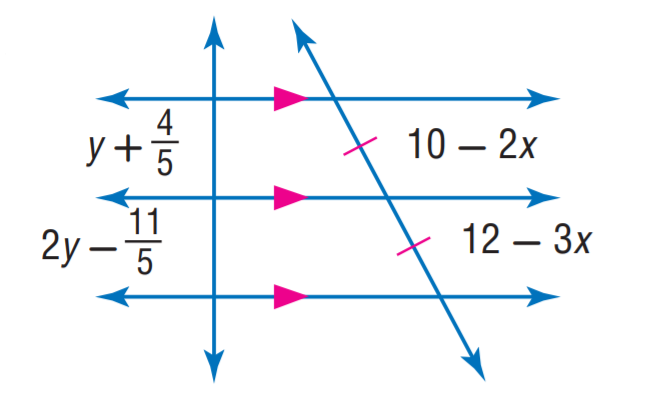Answer the mathemtical geometry problem and directly provide the correct option letter.
Question: Find y.
Choices: A: 1 B: 2 C: 3 D: 4 C 